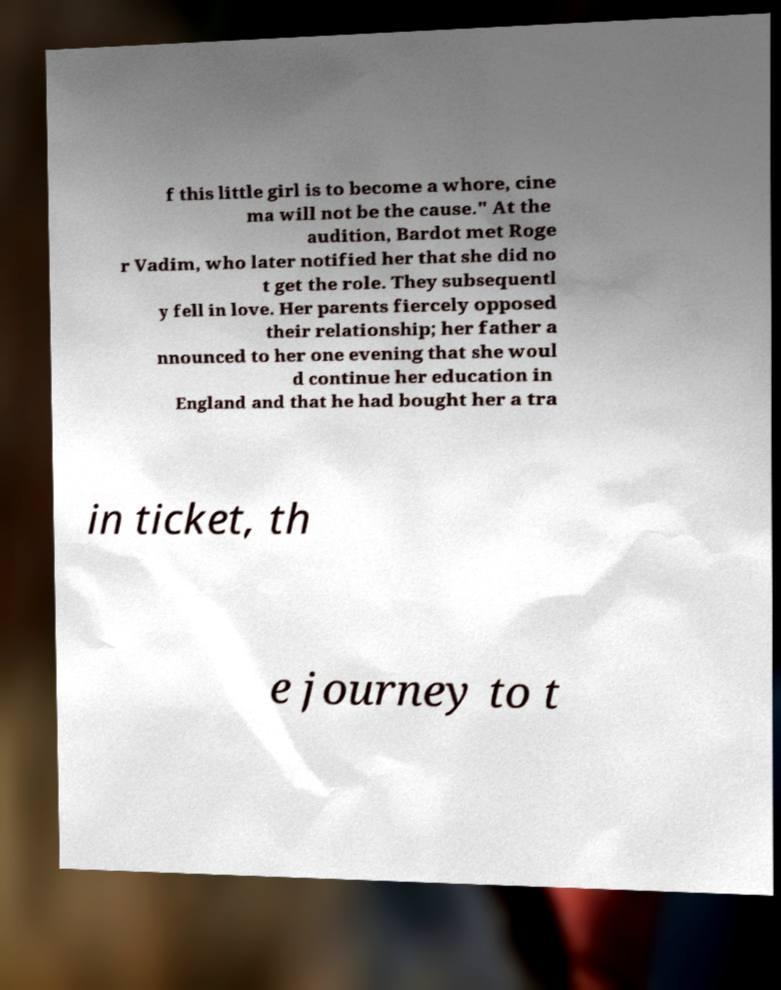Can you accurately transcribe the text from the provided image for me? f this little girl is to become a whore, cine ma will not be the cause." At the audition, Bardot met Roge r Vadim, who later notified her that she did no t get the role. They subsequentl y fell in love. Her parents fiercely opposed their relationship; her father a nnounced to her one evening that she woul d continue her education in England and that he had bought her a tra in ticket, th e journey to t 